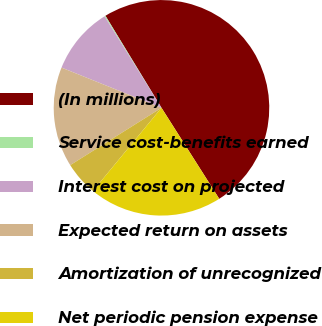Convert chart. <chart><loc_0><loc_0><loc_500><loc_500><pie_chart><fcel>(In millions)<fcel>Service cost-benefits earned<fcel>Interest cost on projected<fcel>Expected return on assets<fcel>Amortization of unrecognized<fcel>Net periodic pension expense<nl><fcel>49.7%<fcel>0.15%<fcel>10.06%<fcel>15.01%<fcel>5.1%<fcel>19.97%<nl></chart> 